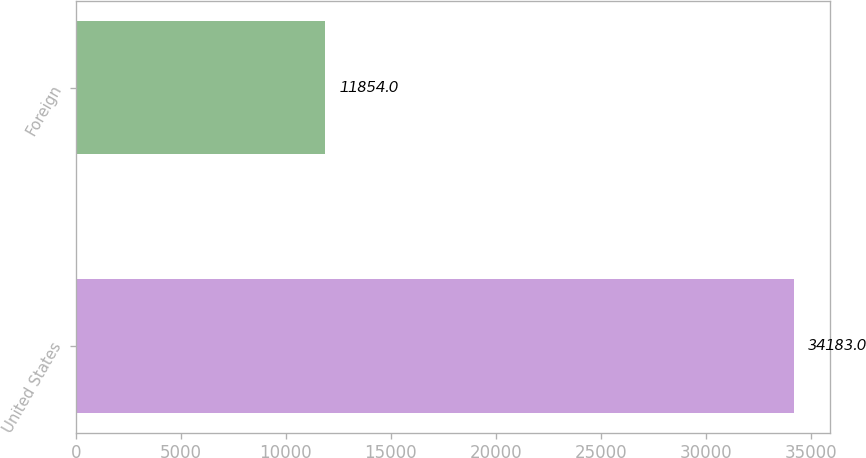Convert chart. <chart><loc_0><loc_0><loc_500><loc_500><bar_chart><fcel>United States<fcel>Foreign<nl><fcel>34183<fcel>11854<nl></chart> 